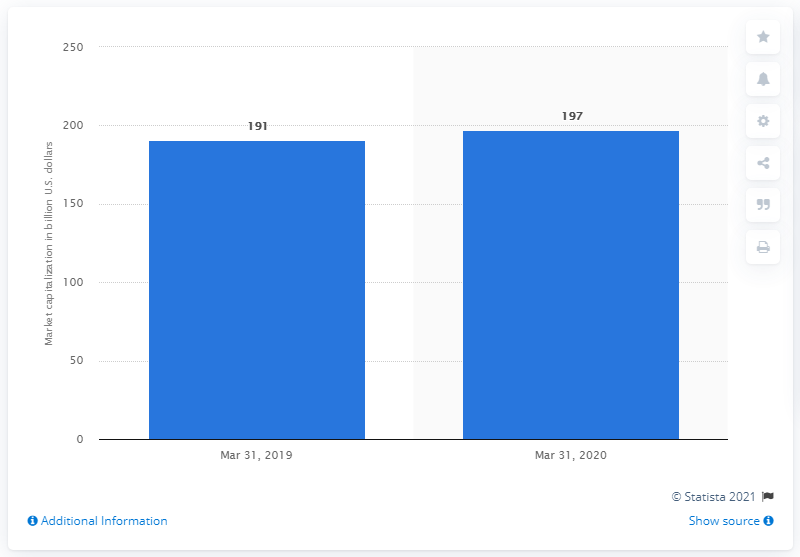Highlight a few significant elements in this photo. At the end of March 2020, Toyota's market capitalization was approximately 197 billion U.S. dollars. 